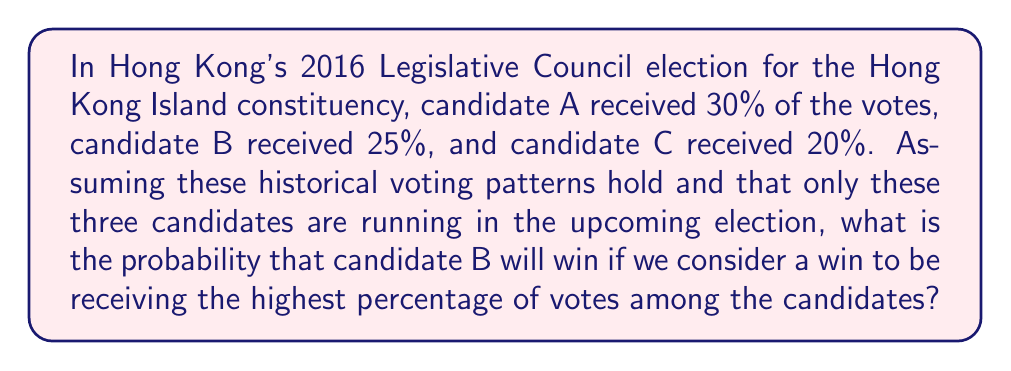Solve this math problem. Let's approach this step-by-step:

1) First, we need to calculate the total percentage of votes accounted for by these three candidates:
   $30\% + 25\% + 20\% = 75\%$

2) We need to normalize these percentages to account for 100% of the votes:
   Candidate A: $30\% / 75\% \times 100\% = 40\%$
   Candidate B: $25\% / 75\% \times 100\% = 33.33\%$
   Candidate C: $20\% / 75\% \times 100\% = 26.67\%$

3) For candidate B to win, they need to receive more votes than both A and C. This can be represented as:
   $P(B > A \text{ and } B > C)$

4) Given the nature of the problem, we can assume that the percentage of votes each candidate receives follows a normal distribution with the mean being their historical percentage.

5) Let's assume a standard deviation of 5% for each candidate. We can then calculate the probability of B beating A and C separately:

   $P(B > A) = P(A - B < 0)$
   $P(A - B < 0) = P(Z < \frac{0 - (40\% - 33.33\%)}{\sqrt{5^2 + 5^2}}) = P(Z < -0.94) = 0.1736$

   $P(B > C) = P(C - B < 0)$
   $P(C - B < 0) = P(Z < \frac{0 - (26.67\% - 33.33\%)}{\sqrt{5^2 + 5^2}}) = P(Z < 0.94) = 0.8264$

6) The probability of B winning is the probability of both these events occurring:
   $P(B \text{ wins}) = P(B > A \text{ and } B > C) = 0.1736 \times 0.8264 = 0.1435$

Therefore, the probability of candidate B winning is approximately 14.35%.
Answer: 0.1435 or 14.35% 